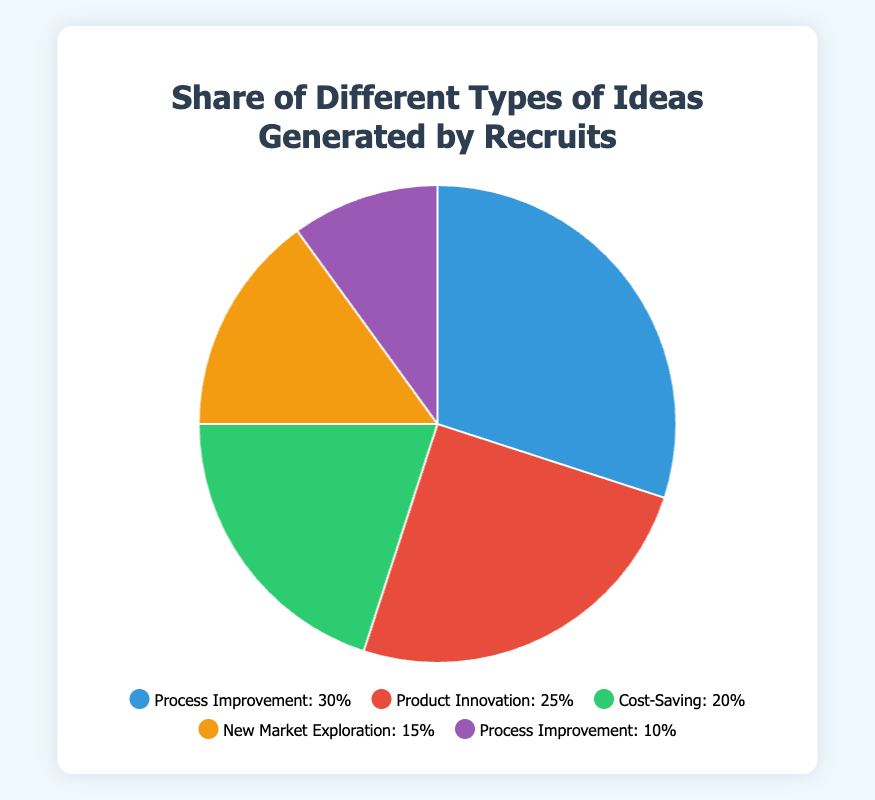Which category has the highest share of ideas? By looking at the pie chart, we can see that the largest section of the pie represents Process Improvement with a share of 30%.
Answer: Process Improvement How much more is the share of Process Improvement compared to New Market Exploration? Process Improvement has a share of 30%, while New Market Exploration has a share of 15%. The difference is 30% - 15% = 15%.
Answer: 15% Which color represents Product Innovation? Observing the legend, the color associated with Product Innovation, with a share of 25%, is red.
Answer: Red What is the combined percentage of ideas that fall under Cost-Saving and New Market Exploration? The share for Cost-Saving is 20% and for New Market Exploration is 15%. Adding these together gives 20% + 15% = 35%.
Answer: 35% Is the share of Product Innovation greater than Cost-Saving? Product Innovation has a share of 25%, while Cost-Saving has a share of 20%. Comparing these percentages, 25% is greater than 20%.
Answer: Yes What is the average share percentage of Process Improvement ideas and Cost-Saving ideas? The share of Process Improvement is 30% and Cost-Saving is 20%. The average is calculated as (30% + 20%) / 2 = 50% / 2 = 25%.
Answer: 25% Which company is associated with the smallest share of ideas, and what is that share? By observing the pie chart, the smallest section represents Process Improvement ideas from Amazon with a share of 10%.
Answer: Amazon, 10% Which idea has the same share percentage as the sum of New Market Exploration and Automating customer service interactions with chatbots? New Market Exploration has a share of 15%, and Automating customer service interactions with chatbots (another Process Improvement idea) has a share of 10%. The sum is 15% + 10% = 25%, which corresponds to the Product Innovation idea from Apple.
Answer: Product Innovation How many categories have a share of 20% or more? By counting from the pie chart, Process Improvement has 30%, Product Innovation has 25%, and Cost-Saving has 20%. This totals to 3 categories.
Answer: 3 